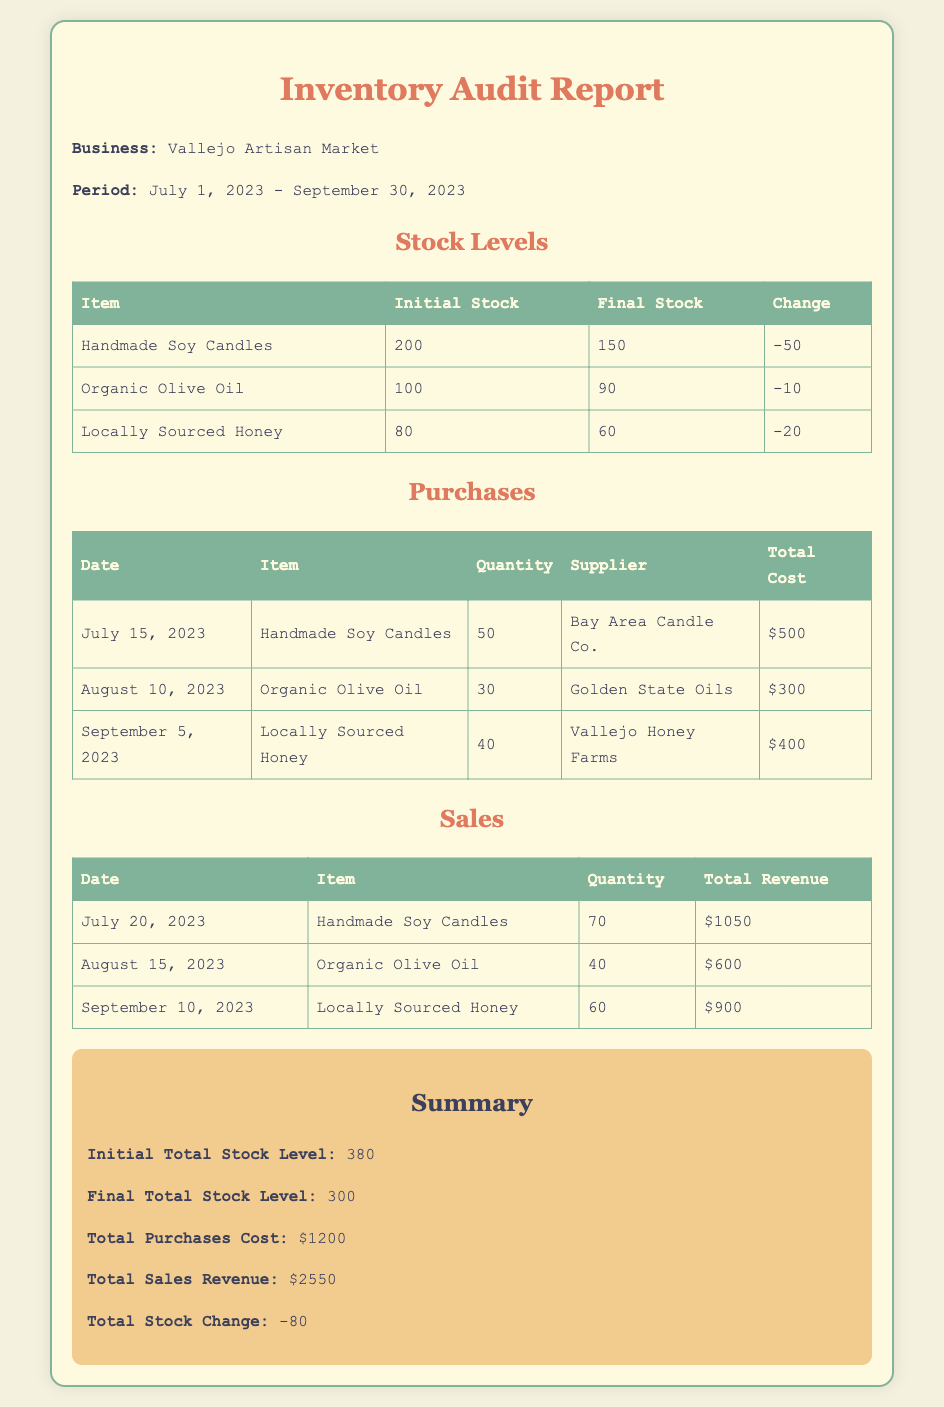what is the business name? The document specifies the name of the business as "Vallejo Artisan Market."
Answer: Vallejo Artisan Market what is the period of the audit report? The document clearly indicates the period covered by the report as "July 1, 2023 - September 30, 2023."
Answer: July 1, 2023 - September 30, 2023 how many Handmade Soy Candles were sold? According to the sales section, 70 Handmade Soy Candles were sold.
Answer: 70 what was the total cost of purchases? The document summarizes total purchases cost as $1200.
Answer: $1200 how much change occurred in Organic Olive Oil stock? The stock change for Organic Olive Oil is given as -10, indicating a decrease.
Answer: -10 what is the total stock level before the audit? The initial total stock level is noted as 380 in the summary section.
Answer: 380 which supplier provided Locally Sourced Honey? The document lists "Vallejo Honey Farms" as the supplier for Locally Sourced Honey.
Answer: Vallejo Honey Farms what was the total sales revenue? The total sales revenue reported in the summary is $2550.
Answer: $2550 how many units of Organic Olive Oil were purchased? The purchases table shows that 30 units of Organic Olive Oil were purchased.
Answer: 30 